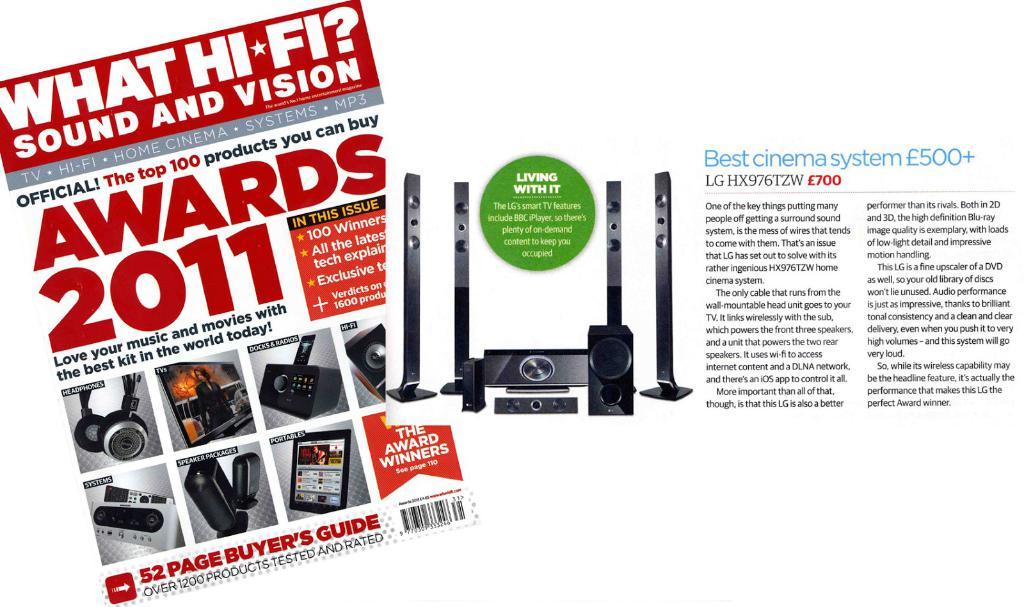What year are these awards from?
Your answer should be very brief. 2011. 